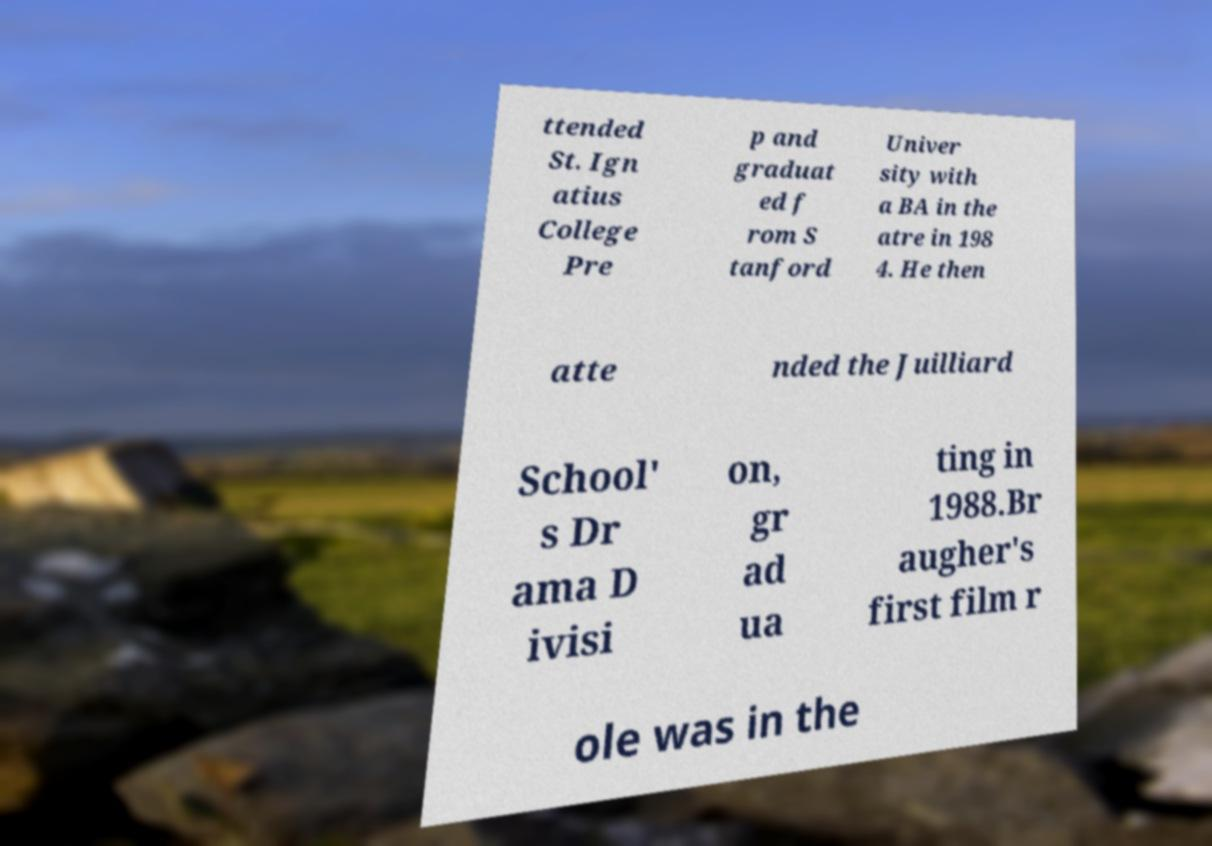Can you read and provide the text displayed in the image?This photo seems to have some interesting text. Can you extract and type it out for me? ttended St. Ign atius College Pre p and graduat ed f rom S tanford Univer sity with a BA in the atre in 198 4. He then atte nded the Juilliard School' s Dr ama D ivisi on, gr ad ua ting in 1988.Br augher's first film r ole was in the 